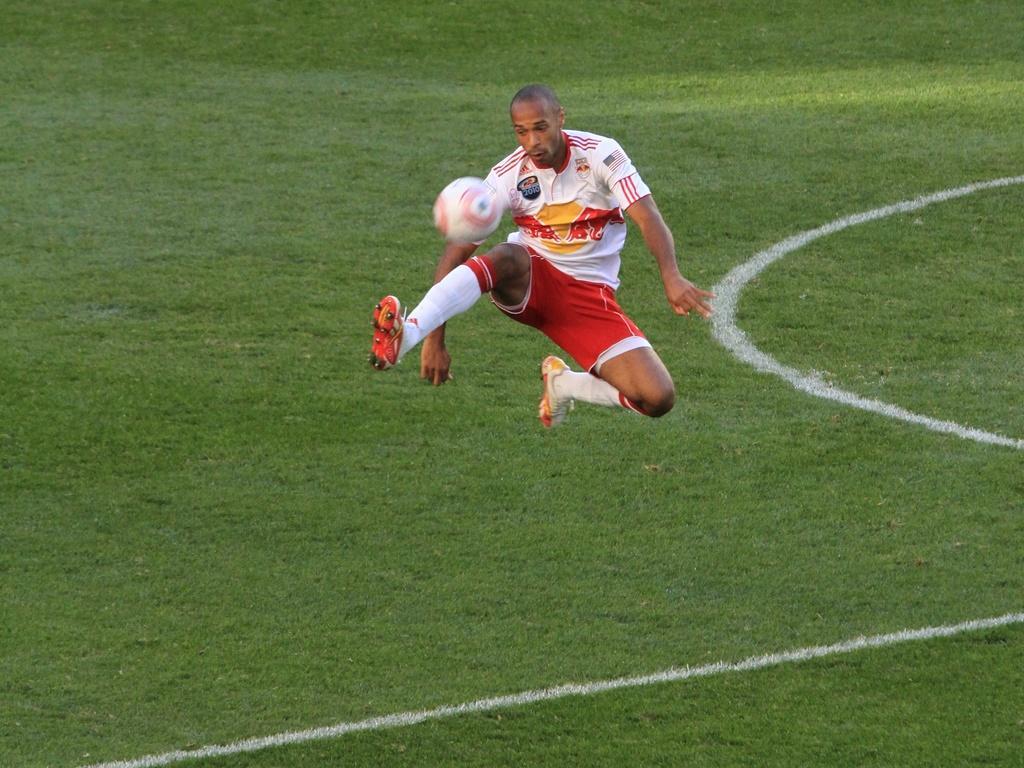Can you describe this image briefly? In this image we can see a person wearing white T-shirt, socks and shoes is in the air, also the ball is in the air. Here we can see the ground. 